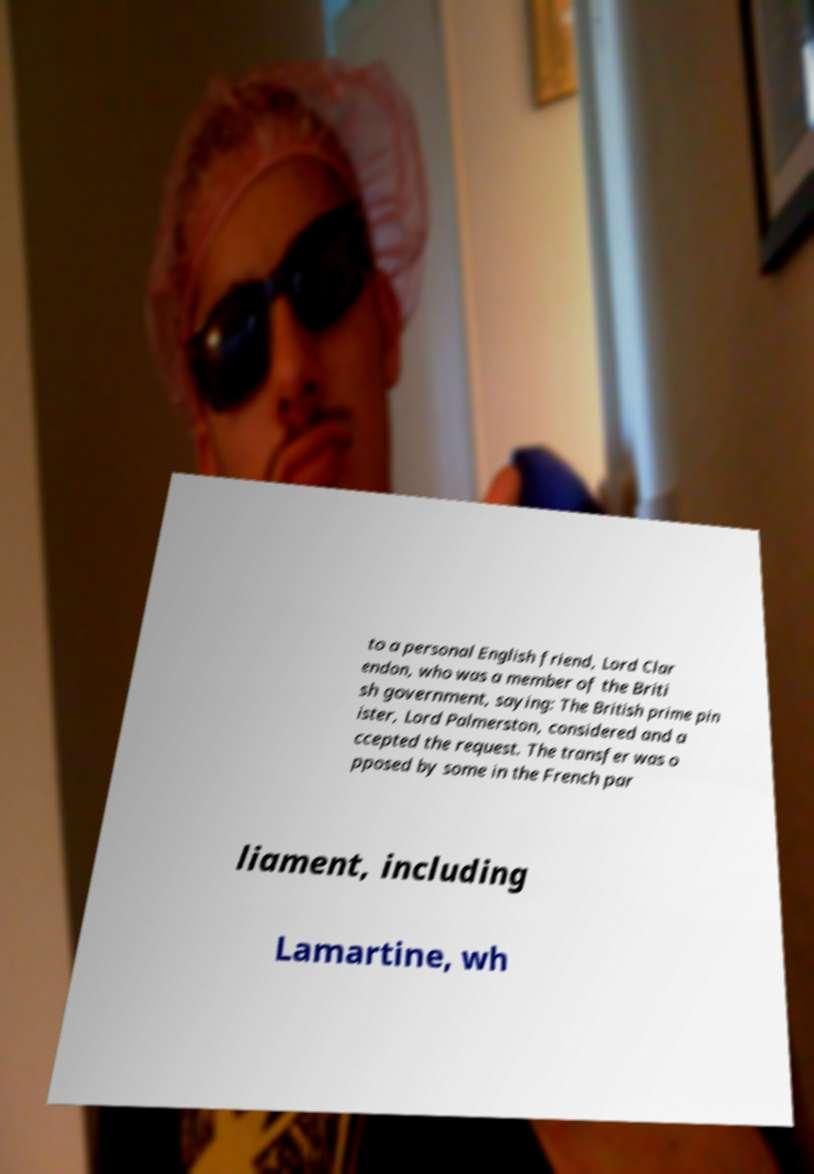Please read and relay the text visible in this image. What does it say? to a personal English friend, Lord Clar endon, who was a member of the Briti sh government, saying: The British prime pin ister, Lord Palmerston, considered and a ccepted the request. The transfer was o pposed by some in the French par liament, including Lamartine, wh 